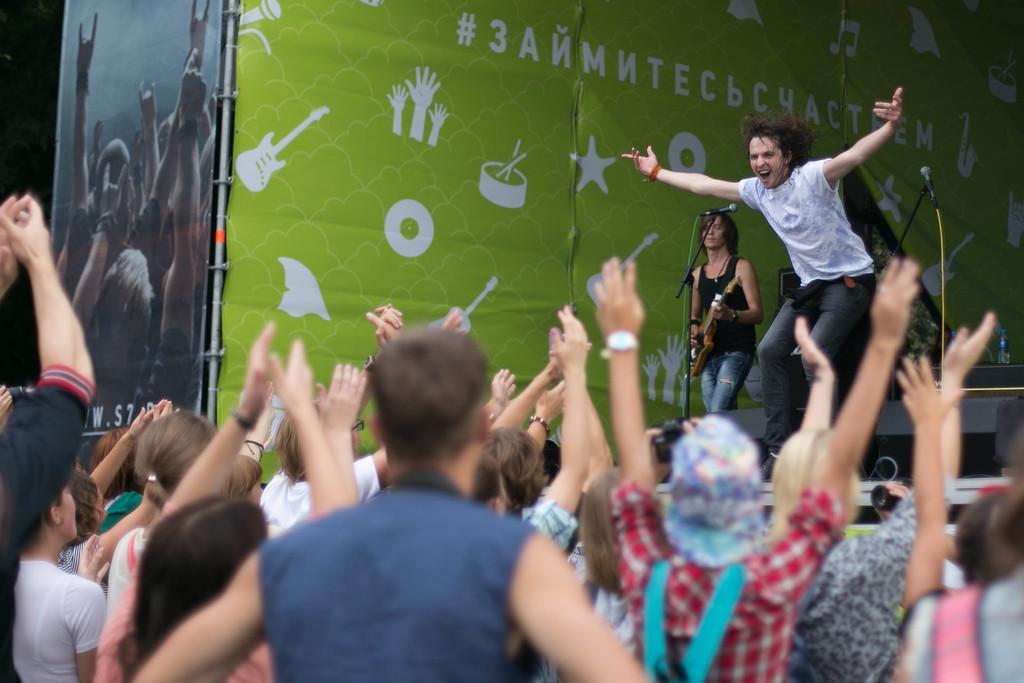Describe this image in one or two sentences. In this image there are people standing by clapping hands in the air. In the background, there is a man standing on the stage and also a woman playing a guitar and also we can see mic stands and the banner wall. 